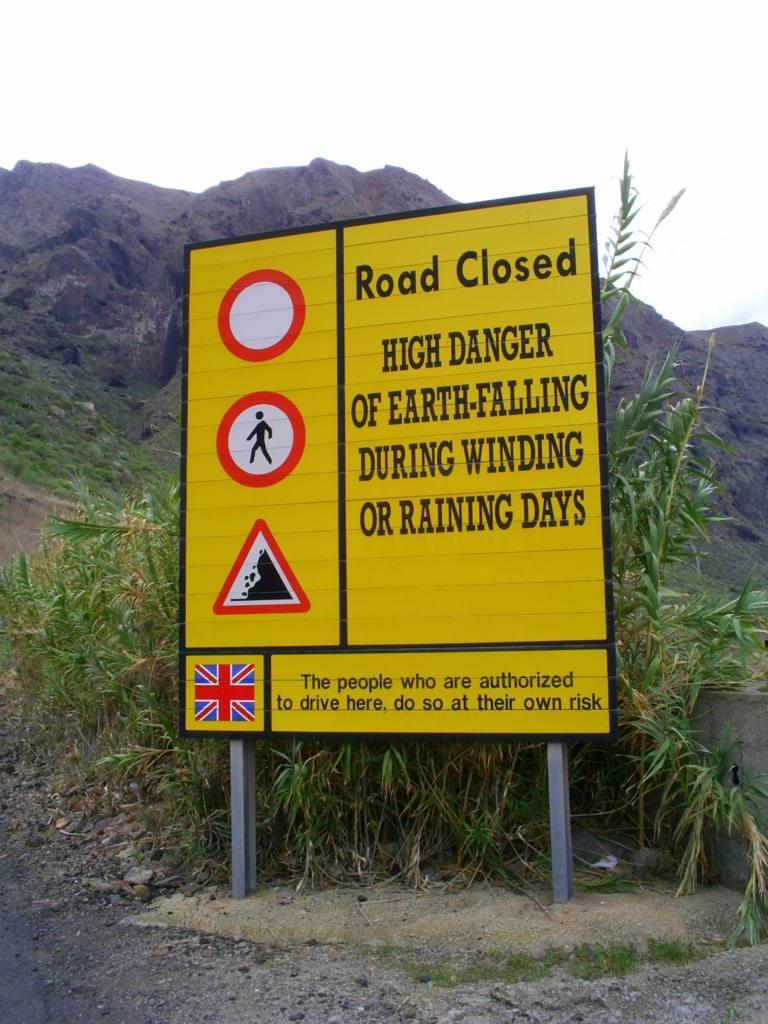What is the main object in the image with signs and text on it? There is a sign board in the image with signs and text on it. What type of natural features can be seen in the image? There are mountains and a rock in the image. What type of vegetation is present in the image? There are plants and grass in the image. What man-made feature can be seen in the image? There is a road in the image. Can you see any fairies flying around the rock in the image? There are no fairies present in the image; it features include mountains, a rock, plants, grass, and a road. Is there a guide available to help navigate the mountains in the image? The image does not show any guides or indicate their presence. 